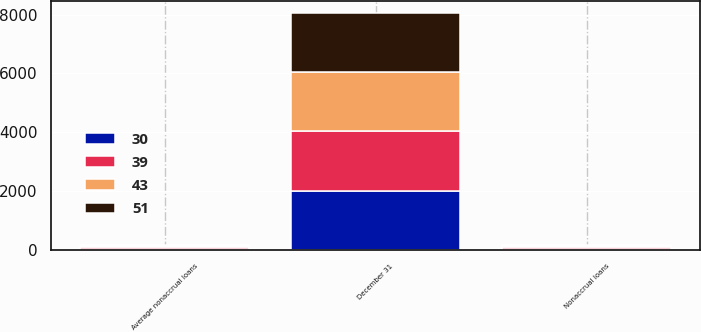Convert chart to OTSL. <chart><loc_0><loc_0><loc_500><loc_500><stacked_bar_chart><ecel><fcel>December 31<fcel>Nonaccrual loans<fcel>Average nonaccrual loans<nl><fcel>51<fcel>2015<fcel>28<fcel>30<nl><fcel>30<fcel>2014<fcel>35<fcel>39<nl><fcel>39<fcel>2013<fcel>48<fcel>43<nl><fcel>43<fcel>2012<fcel>48<fcel>48<nl></chart> 